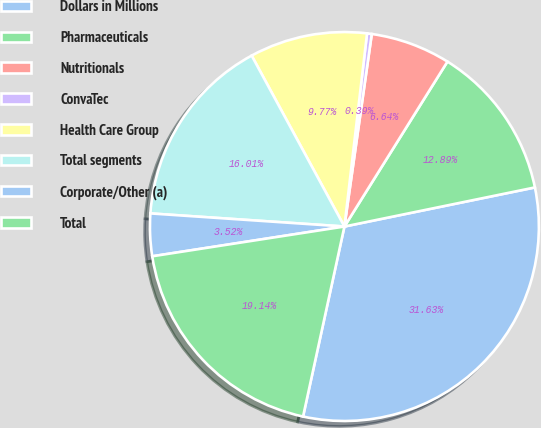<chart> <loc_0><loc_0><loc_500><loc_500><pie_chart><fcel>Dollars in Millions<fcel>Pharmaceuticals<fcel>Nutritionals<fcel>ConvaTec<fcel>Health Care Group<fcel>Total segments<fcel>Corporate/Other (a)<fcel>Total<nl><fcel>31.63%<fcel>12.89%<fcel>6.64%<fcel>0.39%<fcel>9.77%<fcel>16.01%<fcel>3.52%<fcel>19.14%<nl></chart> 